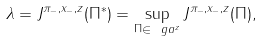<formula> <loc_0><loc_0><loc_500><loc_500>\lambda = J ^ { \pi _ { - } , x _ { - } , z } ( \Pi ^ { * } ) = \sup _ { \Pi \in \ g a ^ { z } } J ^ { \pi _ { - } , x _ { - } , z } ( \Pi ) ,</formula> 